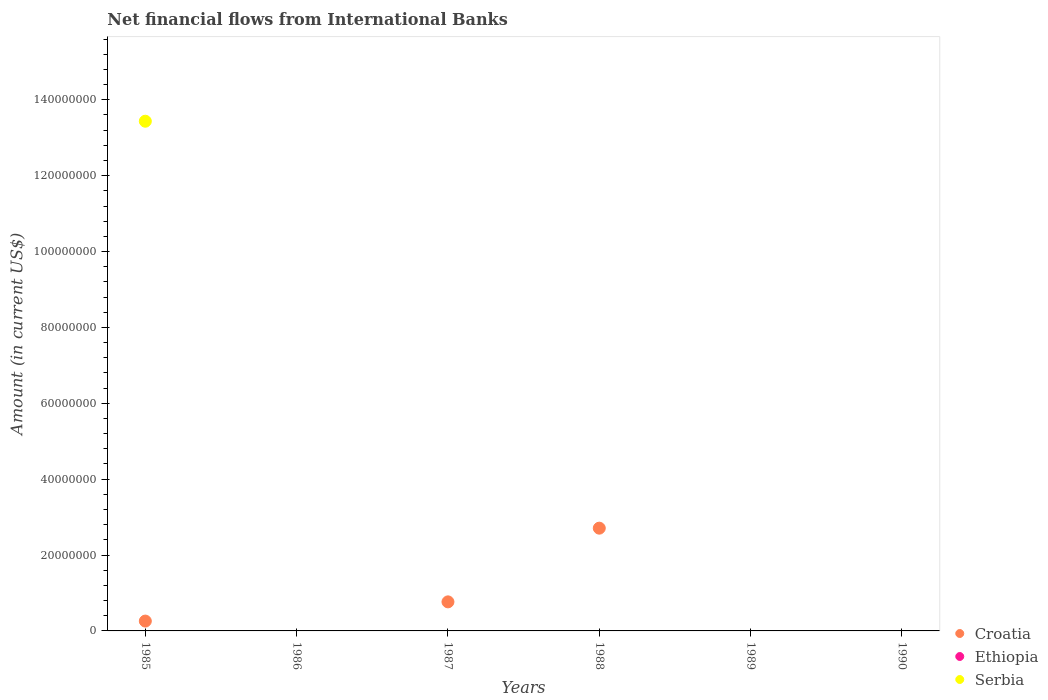Is the number of dotlines equal to the number of legend labels?
Offer a very short reply. No. What is the net financial aid flows in Croatia in 1987?
Your response must be concise. 7.66e+06. Across all years, what is the maximum net financial aid flows in Serbia?
Ensure brevity in your answer.  1.34e+08. In which year was the net financial aid flows in Serbia maximum?
Keep it short and to the point. 1985. What is the difference between the net financial aid flows in Croatia in 1987 and that in 1988?
Offer a terse response. -1.94e+07. What is the difference between the net financial aid flows in Ethiopia in 1989 and the net financial aid flows in Croatia in 1990?
Offer a very short reply. 0. What is the average net financial aid flows in Ethiopia per year?
Provide a succinct answer. 0. In the year 1985, what is the difference between the net financial aid flows in Serbia and net financial aid flows in Croatia?
Keep it short and to the point. 1.32e+08. In how many years, is the net financial aid flows in Ethiopia greater than 144000000 US$?
Make the answer very short. 0. What is the ratio of the net financial aid flows in Croatia in 1985 to that in 1988?
Your response must be concise. 0.1. What is the difference between the highest and the second highest net financial aid flows in Croatia?
Your response must be concise. 1.94e+07. What is the difference between the highest and the lowest net financial aid flows in Serbia?
Give a very brief answer. 1.34e+08. Is the net financial aid flows in Croatia strictly greater than the net financial aid flows in Ethiopia over the years?
Your answer should be compact. No. Are the values on the major ticks of Y-axis written in scientific E-notation?
Your response must be concise. No. Where does the legend appear in the graph?
Provide a short and direct response. Bottom right. What is the title of the graph?
Keep it short and to the point. Net financial flows from International Banks. Does "Russian Federation" appear as one of the legend labels in the graph?
Offer a very short reply. No. What is the Amount (in current US$) in Croatia in 1985?
Ensure brevity in your answer.  2.59e+06. What is the Amount (in current US$) in Ethiopia in 1985?
Offer a very short reply. 0. What is the Amount (in current US$) of Serbia in 1985?
Make the answer very short. 1.34e+08. What is the Amount (in current US$) in Croatia in 1986?
Provide a short and direct response. 0. What is the Amount (in current US$) of Serbia in 1986?
Make the answer very short. 0. What is the Amount (in current US$) of Croatia in 1987?
Keep it short and to the point. 7.66e+06. What is the Amount (in current US$) of Ethiopia in 1987?
Provide a short and direct response. 0. What is the Amount (in current US$) in Croatia in 1988?
Ensure brevity in your answer.  2.71e+07. What is the Amount (in current US$) of Ethiopia in 1988?
Give a very brief answer. 0. What is the Amount (in current US$) of Croatia in 1989?
Ensure brevity in your answer.  0. What is the Amount (in current US$) of Serbia in 1989?
Offer a terse response. 0. What is the Amount (in current US$) of Serbia in 1990?
Your answer should be compact. 0. Across all years, what is the maximum Amount (in current US$) of Croatia?
Offer a terse response. 2.71e+07. Across all years, what is the maximum Amount (in current US$) in Serbia?
Keep it short and to the point. 1.34e+08. Across all years, what is the minimum Amount (in current US$) of Croatia?
Provide a succinct answer. 0. What is the total Amount (in current US$) of Croatia in the graph?
Offer a very short reply. 3.73e+07. What is the total Amount (in current US$) in Serbia in the graph?
Provide a short and direct response. 1.34e+08. What is the difference between the Amount (in current US$) of Croatia in 1985 and that in 1987?
Your answer should be compact. -5.07e+06. What is the difference between the Amount (in current US$) of Croatia in 1985 and that in 1988?
Your response must be concise. -2.45e+07. What is the difference between the Amount (in current US$) in Croatia in 1987 and that in 1988?
Provide a succinct answer. -1.94e+07. What is the average Amount (in current US$) of Croatia per year?
Ensure brevity in your answer.  6.22e+06. What is the average Amount (in current US$) of Serbia per year?
Make the answer very short. 2.24e+07. In the year 1985, what is the difference between the Amount (in current US$) in Croatia and Amount (in current US$) in Serbia?
Give a very brief answer. -1.32e+08. What is the ratio of the Amount (in current US$) in Croatia in 1985 to that in 1987?
Your answer should be very brief. 0.34. What is the ratio of the Amount (in current US$) of Croatia in 1985 to that in 1988?
Offer a very short reply. 0.1. What is the ratio of the Amount (in current US$) in Croatia in 1987 to that in 1988?
Provide a short and direct response. 0.28. What is the difference between the highest and the second highest Amount (in current US$) in Croatia?
Offer a terse response. 1.94e+07. What is the difference between the highest and the lowest Amount (in current US$) of Croatia?
Make the answer very short. 2.71e+07. What is the difference between the highest and the lowest Amount (in current US$) in Serbia?
Your answer should be compact. 1.34e+08. 